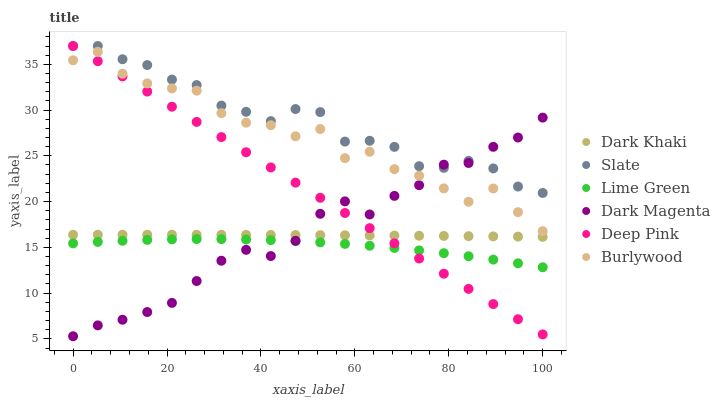Does Lime Green have the minimum area under the curve?
Answer yes or no. Yes. Does Slate have the maximum area under the curve?
Answer yes or no. Yes. Does Dark Magenta have the minimum area under the curve?
Answer yes or no. No. Does Dark Magenta have the maximum area under the curve?
Answer yes or no. No. Is Deep Pink the smoothest?
Answer yes or no. Yes. Is Burlywood the roughest?
Answer yes or no. Yes. Is Dark Magenta the smoothest?
Answer yes or no. No. Is Dark Magenta the roughest?
Answer yes or no. No. Does Dark Magenta have the lowest value?
Answer yes or no. Yes. Does Burlywood have the lowest value?
Answer yes or no. No. Does Slate have the highest value?
Answer yes or no. Yes. Does Dark Magenta have the highest value?
Answer yes or no. No. Is Dark Khaki less than Burlywood?
Answer yes or no. Yes. Is Slate greater than Lime Green?
Answer yes or no. Yes. Does Burlywood intersect Dark Magenta?
Answer yes or no. Yes. Is Burlywood less than Dark Magenta?
Answer yes or no. No. Is Burlywood greater than Dark Magenta?
Answer yes or no. No. Does Dark Khaki intersect Burlywood?
Answer yes or no. No. 